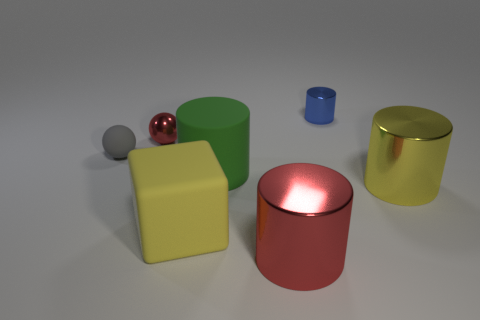What number of blocks are in front of the yellow object that is to the right of the tiny cylinder?
Your answer should be very brief. 1. There is a red thing that is the same shape as the blue metallic object; what material is it?
Provide a short and direct response. Metal. There is a cylinder behind the small gray matte object; is it the same color as the big matte block?
Offer a terse response. No. Is the material of the green thing the same as the sphere that is behind the small gray rubber thing?
Offer a very short reply. No. There is a red object behind the gray object; what is its shape?
Offer a very short reply. Sphere. What number of other things are there of the same material as the gray object
Your response must be concise. 2. How big is the yellow cylinder?
Provide a succinct answer. Large. How many other things are there of the same color as the rubber cylinder?
Keep it short and to the point. 0. What color is the rubber object that is behind the yellow rubber thing and on the right side of the small red sphere?
Provide a short and direct response. Green. How many small cyan objects are there?
Keep it short and to the point. 0. 